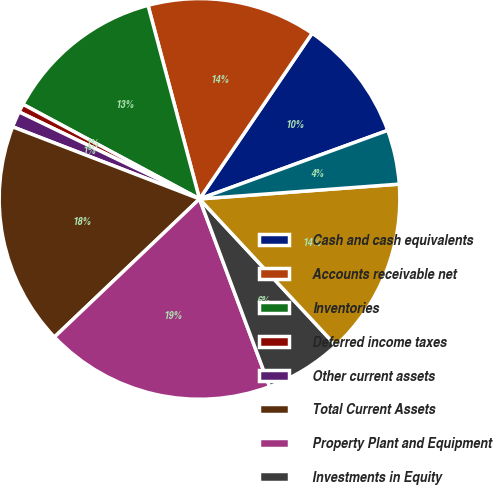Convert chart to OTSL. <chart><loc_0><loc_0><loc_500><loc_500><pie_chart><fcel>Cash and cash equivalents<fcel>Accounts receivable net<fcel>Inventories<fcel>Deferred income taxes<fcel>Other current assets<fcel>Total Current Assets<fcel>Property Plant and Equipment<fcel>Investments in Equity<fcel>Goodwill<fcel>Other Intangible Assets<nl><fcel>9.94%<fcel>13.64%<fcel>13.03%<fcel>0.68%<fcel>1.29%<fcel>17.97%<fcel>18.58%<fcel>6.23%<fcel>14.26%<fcel>4.38%<nl></chart> 